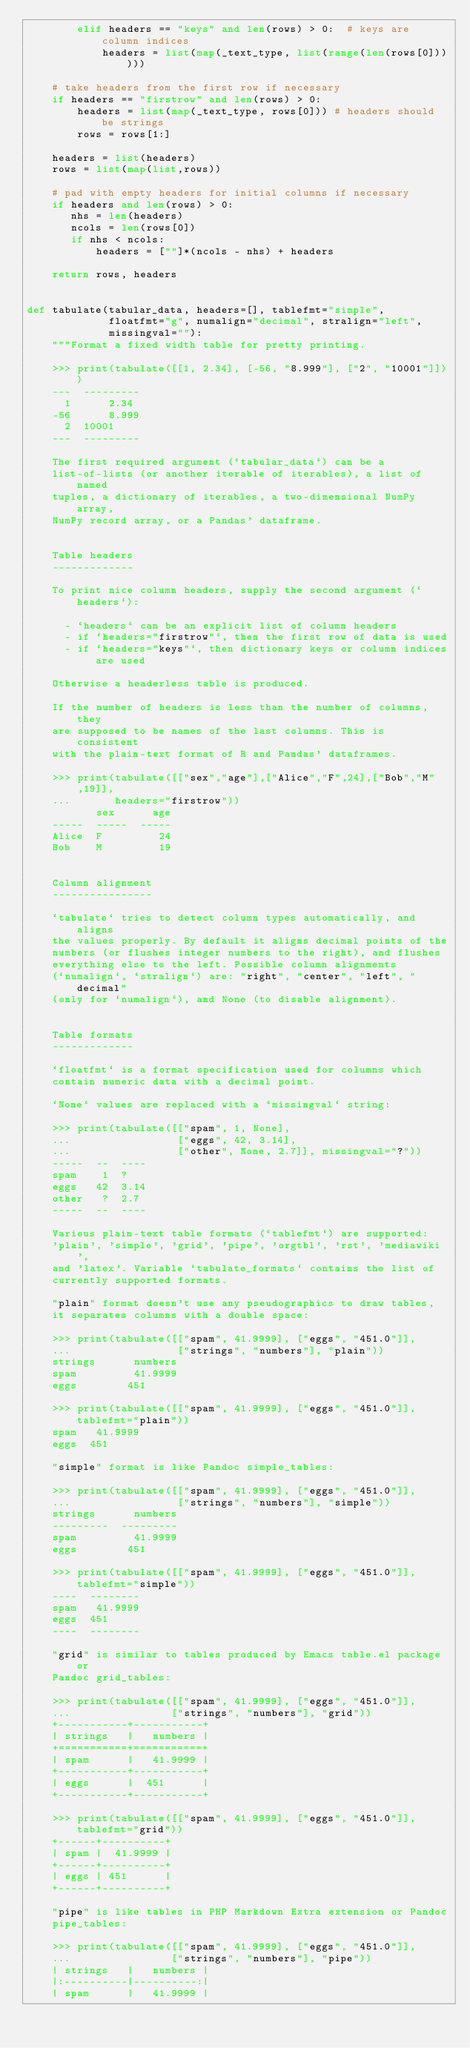<code> <loc_0><loc_0><loc_500><loc_500><_Python_>        elif headers == "keys" and len(rows) > 0:  # keys are column indices
            headers = list(map(_text_type, list(range(len(rows[0])))))

    # take headers from the first row if necessary
    if headers == "firstrow" and len(rows) > 0:
        headers = list(map(_text_type, rows[0])) # headers should be strings
        rows = rows[1:]

    headers = list(headers)
    rows = list(map(list,rows))

    # pad with empty headers for initial columns if necessary
    if headers and len(rows) > 0:
       nhs = len(headers)
       ncols = len(rows[0])
       if nhs < ncols:
           headers = [""]*(ncols - nhs) + headers

    return rows, headers


def tabulate(tabular_data, headers=[], tablefmt="simple",
             floatfmt="g", numalign="decimal", stralign="left",
             missingval=""):
    """Format a fixed width table for pretty printing.

    >>> print(tabulate([[1, 2.34], [-56, "8.999"], ["2", "10001"]]))
    ---  ---------
      1      2.34
    -56      8.999
      2  10001
    ---  ---------

    The first required argument (`tabular_data`) can be a
    list-of-lists (or another iterable of iterables), a list of named
    tuples, a dictionary of iterables, a two-dimensional NumPy array,
    NumPy record array, or a Pandas' dataframe.


    Table headers
    -------------

    To print nice column headers, supply the second argument (`headers`):

      - `headers` can be an explicit list of column headers
      - if `headers="firstrow"`, then the first row of data is used
      - if `headers="keys"`, then dictionary keys or column indices are used

    Otherwise a headerless table is produced.

    If the number of headers is less than the number of columns, they
    are supposed to be names of the last columns. This is consistent
    with the plain-text format of R and Pandas' dataframes.

    >>> print(tabulate([["sex","age"],["Alice","F",24],["Bob","M",19]],
    ...       headers="firstrow"))
           sex      age
    -----  -----  -----
    Alice  F         24
    Bob    M         19


    Column alignment
    ----------------

    `tabulate` tries to detect column types automatically, and aligns
    the values properly. By default it aligns decimal points of the
    numbers (or flushes integer numbers to the right), and flushes
    everything else to the left. Possible column alignments
    (`numalign`, `stralign`) are: "right", "center", "left", "decimal"
    (only for `numalign`), and None (to disable alignment).


    Table formats
    -------------

    `floatfmt` is a format specification used for columns which
    contain numeric data with a decimal point.

    `None` values are replaced with a `missingval` string:

    >>> print(tabulate([["spam", 1, None],
    ...                 ["eggs", 42, 3.14],
    ...                 ["other", None, 2.7]], missingval="?"))
    -----  --  ----
    spam    1  ?
    eggs   42  3.14
    other   ?  2.7
    -----  --  ----

    Various plain-text table formats (`tablefmt`) are supported:
    'plain', 'simple', 'grid', 'pipe', 'orgtbl', 'rst', 'mediawiki',
    and 'latex'. Variable `tabulate_formats` contains the list of
    currently supported formats.

    "plain" format doesn't use any pseudographics to draw tables,
    it separates columns with a double space:

    >>> print(tabulate([["spam", 41.9999], ["eggs", "451.0"]],
    ...                 ["strings", "numbers"], "plain"))
    strings      numbers
    spam         41.9999
    eggs        451

    >>> print(tabulate([["spam", 41.9999], ["eggs", "451.0"]], tablefmt="plain"))
    spam   41.9999
    eggs  451

    "simple" format is like Pandoc simple_tables:

    >>> print(tabulate([["spam", 41.9999], ["eggs", "451.0"]],
    ...                 ["strings", "numbers"], "simple"))
    strings      numbers
    ---------  ---------
    spam         41.9999
    eggs        451

    >>> print(tabulate([["spam", 41.9999], ["eggs", "451.0"]], tablefmt="simple"))
    ----  --------
    spam   41.9999
    eggs  451
    ----  --------

    "grid" is similar to tables produced by Emacs table.el package or
    Pandoc grid_tables:

    >>> print(tabulate([["spam", 41.9999], ["eggs", "451.0"]],
    ...                ["strings", "numbers"], "grid"))
    +-----------+-----------+
    | strings   |   numbers |
    +===========+===========+
    | spam      |   41.9999 |
    +-----------+-----------+
    | eggs      |  451      |
    +-----------+-----------+

    >>> print(tabulate([["spam", 41.9999], ["eggs", "451.0"]], tablefmt="grid"))
    +------+----------+
    | spam |  41.9999 |
    +------+----------+
    | eggs | 451      |
    +------+----------+

    "pipe" is like tables in PHP Markdown Extra extension or Pandoc
    pipe_tables:

    >>> print(tabulate([["spam", 41.9999], ["eggs", "451.0"]],
    ...                ["strings", "numbers"], "pipe"))
    | strings   |   numbers |
    |:----------|----------:|
    | spam      |   41.9999 |</code> 